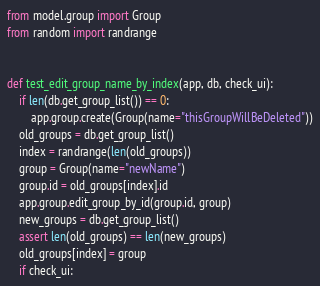Convert code to text. <code><loc_0><loc_0><loc_500><loc_500><_Python_>from model.group import Group
from random import randrange


def test_edit_group_name_by_index(app, db, check_ui):
    if len(db.get_group_list()) == 0:
        app.group.create(Group(name="thisGroupWillBeDeleted"))
    old_groups = db.get_group_list()
    index = randrange(len(old_groups))
    group = Group(name="newName")
    group.id = old_groups[index].id
    app.group.edit_group_by_id(group.id, group)
    new_groups = db.get_group_list()
    assert len(old_groups) == len(new_groups)
    old_groups[index] = group
    if check_ui:</code> 